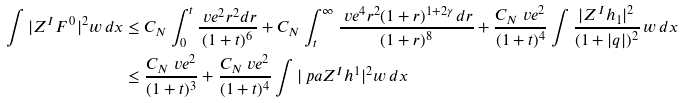Convert formula to latex. <formula><loc_0><loc_0><loc_500><loc_500>\int | Z ^ { I } F ^ { \, 0 } | ^ { 2 } w \, d x & \leq C _ { N } \int _ { 0 } ^ { t } \frac { \ v e ^ { 2 } r ^ { 2 } d r } { ( 1 + t ) ^ { 6 } } + C _ { N } \int _ { t } ^ { \infty } \frac { \ v e ^ { 4 } r ^ { 2 } ( 1 + r ) ^ { 1 + 2 \gamma } \, d r } { ( 1 + r ) ^ { 8 } } + \frac { C _ { N } \ v e ^ { 2 } } { ( 1 + t ) ^ { 4 } } \int \frac { | Z ^ { I } h _ { 1 } | ^ { 2 } } { ( 1 + | q | ) ^ { 2 } } \, w \, d x \\ & \leq \frac { C _ { N } \ v e ^ { 2 } } { ( 1 + t ) ^ { 3 } } + \frac { C _ { N } \ v e ^ { 2 } } { ( 1 + t ) ^ { 4 } } \int | \ p a Z ^ { I } h ^ { 1 } | ^ { 2 } w \, d x</formula> 